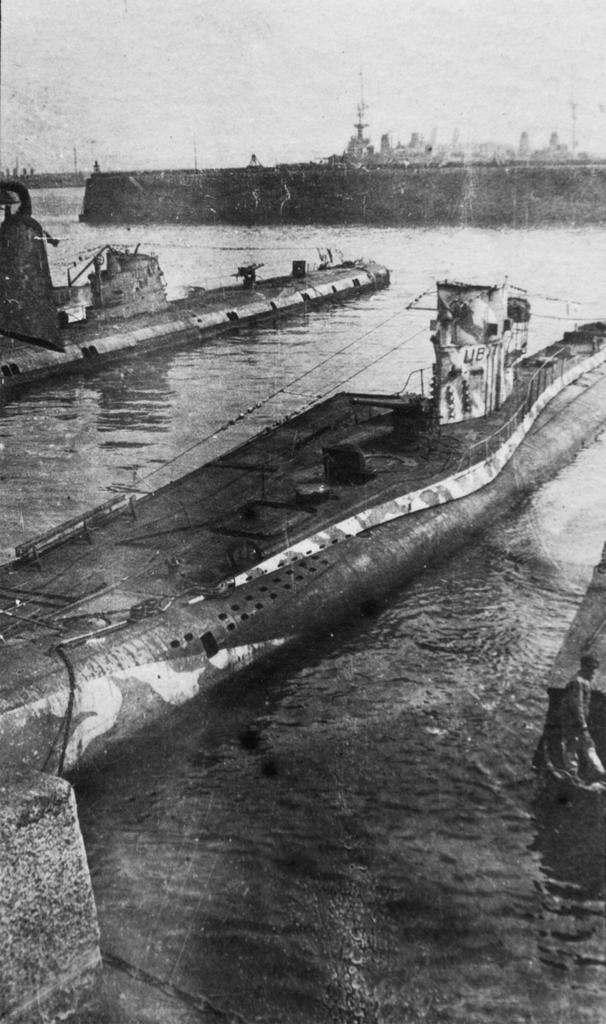What is the color scheme of the image? The image is black and white. What can be seen in the image? There are ships in the image. Where are the ships located? The ships are on the surface of water. What type of home can be seen in the image? There is no home present in the image; it features ships on the surface of water. How many baskets are visible in the image? There are no baskets present in the image. 